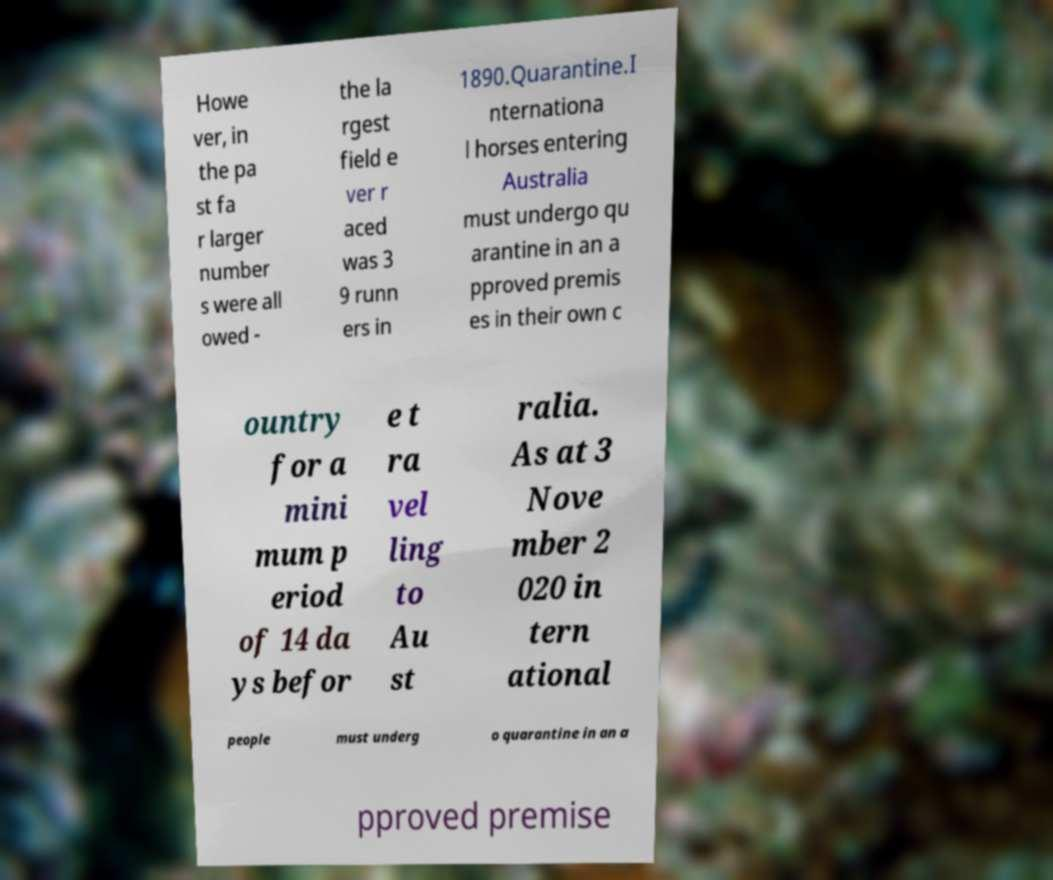For documentation purposes, I need the text within this image transcribed. Could you provide that? Howe ver, in the pa st fa r larger number s were all owed - the la rgest field e ver r aced was 3 9 runn ers in 1890.Quarantine.I nternationa l horses entering Australia must undergo qu arantine in an a pproved premis es in their own c ountry for a mini mum p eriod of 14 da ys befor e t ra vel ling to Au st ralia. As at 3 Nove mber 2 020 in tern ational people must underg o quarantine in an a pproved premise 